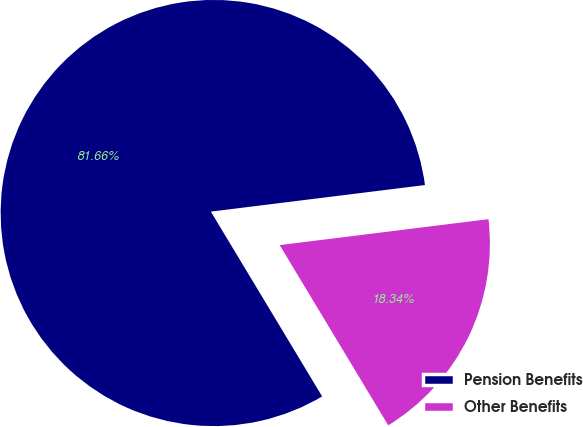Convert chart. <chart><loc_0><loc_0><loc_500><loc_500><pie_chart><fcel>Pension Benefits<fcel>Other Benefits<nl><fcel>81.66%<fcel>18.34%<nl></chart> 